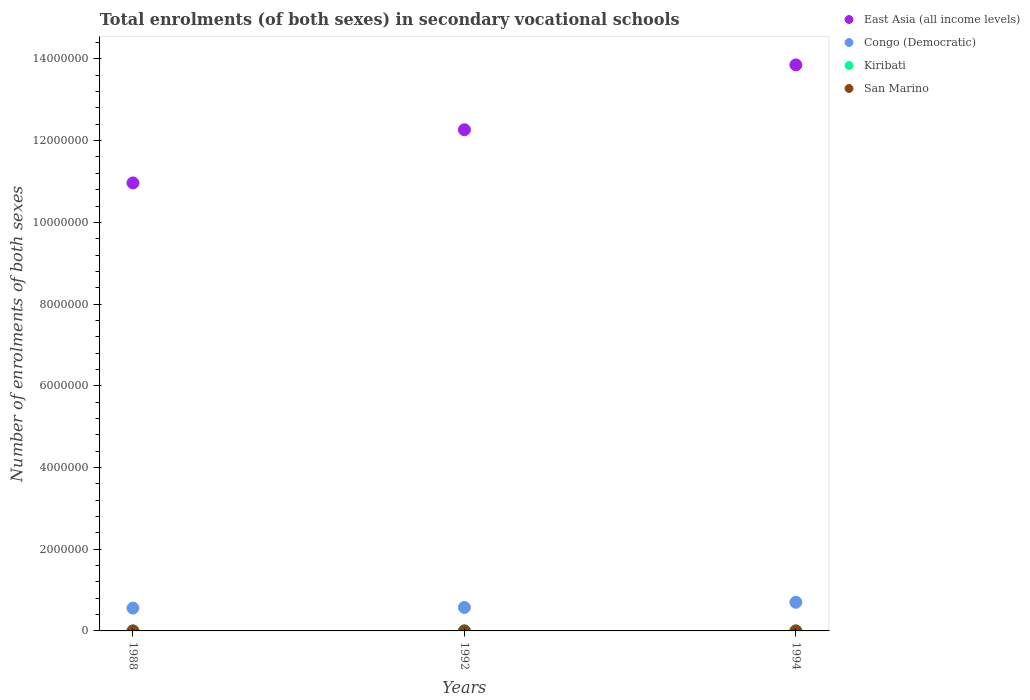How many different coloured dotlines are there?
Offer a very short reply. 4. What is the number of enrolments in secondary schools in Congo (Democratic) in 1992?
Your answer should be compact. 5.74e+05. Across all years, what is the maximum number of enrolments in secondary schools in Congo (Democratic)?
Offer a very short reply. 7.01e+05. Across all years, what is the minimum number of enrolments in secondary schools in East Asia (all income levels)?
Give a very brief answer. 1.10e+07. What is the total number of enrolments in secondary schools in San Marino in the graph?
Give a very brief answer. 414. What is the difference between the number of enrolments in secondary schools in San Marino in 1988 and that in 1992?
Provide a succinct answer. -23. What is the difference between the number of enrolments in secondary schools in East Asia (all income levels) in 1988 and the number of enrolments in secondary schools in San Marino in 1994?
Ensure brevity in your answer.  1.10e+07. What is the average number of enrolments in secondary schools in Congo (Democratic) per year?
Give a very brief answer. 6.11e+05. In the year 1988, what is the difference between the number of enrolments in secondary schools in East Asia (all income levels) and number of enrolments in secondary schools in San Marino?
Your answer should be compact. 1.10e+07. What is the ratio of the number of enrolments in secondary schools in Congo (Democratic) in 1992 to that in 1994?
Provide a short and direct response. 0.82. Is the number of enrolments in secondary schools in East Asia (all income levels) in 1992 less than that in 1994?
Offer a terse response. Yes. What is the difference between the highest and the second highest number of enrolments in secondary schools in East Asia (all income levels)?
Keep it short and to the point. 1.59e+06. What is the difference between the highest and the lowest number of enrolments in secondary schools in East Asia (all income levels)?
Provide a succinct answer. 2.89e+06. In how many years, is the number of enrolments in secondary schools in Congo (Democratic) greater than the average number of enrolments in secondary schools in Congo (Democratic) taken over all years?
Offer a terse response. 1. Is the sum of the number of enrolments in secondary schools in Congo (Democratic) in 1992 and 1994 greater than the maximum number of enrolments in secondary schools in San Marino across all years?
Ensure brevity in your answer.  Yes. Is it the case that in every year, the sum of the number of enrolments in secondary schools in Congo (Democratic) and number of enrolments in secondary schools in East Asia (all income levels)  is greater than the sum of number of enrolments in secondary schools in Kiribati and number of enrolments in secondary schools in San Marino?
Ensure brevity in your answer.  Yes. Is it the case that in every year, the sum of the number of enrolments in secondary schools in San Marino and number of enrolments in secondary schools in Congo (Democratic)  is greater than the number of enrolments in secondary schools in Kiribati?
Your response must be concise. Yes. Is the number of enrolments in secondary schools in San Marino strictly greater than the number of enrolments in secondary schools in Kiribati over the years?
Make the answer very short. No. Is the number of enrolments in secondary schools in East Asia (all income levels) strictly less than the number of enrolments in secondary schools in Kiribati over the years?
Keep it short and to the point. No. How many dotlines are there?
Ensure brevity in your answer.  4. What is the difference between two consecutive major ticks on the Y-axis?
Offer a very short reply. 2.00e+06. Does the graph contain any zero values?
Provide a succinct answer. No. Does the graph contain grids?
Make the answer very short. No. Where does the legend appear in the graph?
Make the answer very short. Top right. How many legend labels are there?
Ensure brevity in your answer.  4. What is the title of the graph?
Provide a short and direct response. Total enrolments (of both sexes) in secondary vocational schools. Does "Brazil" appear as one of the legend labels in the graph?
Ensure brevity in your answer.  No. What is the label or title of the Y-axis?
Keep it short and to the point. Number of enrolments of both sexes. What is the Number of enrolments of both sexes in East Asia (all income levels) in 1988?
Offer a very short reply. 1.10e+07. What is the Number of enrolments of both sexes of Congo (Democratic) in 1988?
Give a very brief answer. 5.58e+05. What is the Number of enrolments of both sexes of Kiribati in 1988?
Your answer should be very brief. 410. What is the Number of enrolments of both sexes in San Marino in 1988?
Offer a very short reply. 114. What is the Number of enrolments of both sexes in East Asia (all income levels) in 1992?
Provide a short and direct response. 1.23e+07. What is the Number of enrolments of both sexes in Congo (Democratic) in 1992?
Your answer should be compact. 5.74e+05. What is the Number of enrolments of both sexes in Kiribati in 1992?
Make the answer very short. 288. What is the Number of enrolments of both sexes of San Marino in 1992?
Make the answer very short. 137. What is the Number of enrolments of both sexes in East Asia (all income levels) in 1994?
Provide a short and direct response. 1.39e+07. What is the Number of enrolments of both sexes in Congo (Democratic) in 1994?
Make the answer very short. 7.01e+05. What is the Number of enrolments of both sexes of Kiribati in 1994?
Keep it short and to the point. 352. What is the Number of enrolments of both sexes of San Marino in 1994?
Provide a short and direct response. 163. Across all years, what is the maximum Number of enrolments of both sexes of East Asia (all income levels)?
Your response must be concise. 1.39e+07. Across all years, what is the maximum Number of enrolments of both sexes of Congo (Democratic)?
Offer a very short reply. 7.01e+05. Across all years, what is the maximum Number of enrolments of both sexes of Kiribati?
Provide a short and direct response. 410. Across all years, what is the maximum Number of enrolments of both sexes in San Marino?
Provide a succinct answer. 163. Across all years, what is the minimum Number of enrolments of both sexes of East Asia (all income levels)?
Your answer should be compact. 1.10e+07. Across all years, what is the minimum Number of enrolments of both sexes in Congo (Democratic)?
Your response must be concise. 5.58e+05. Across all years, what is the minimum Number of enrolments of both sexes of Kiribati?
Your answer should be compact. 288. Across all years, what is the minimum Number of enrolments of both sexes of San Marino?
Provide a succinct answer. 114. What is the total Number of enrolments of both sexes of East Asia (all income levels) in the graph?
Offer a terse response. 3.71e+07. What is the total Number of enrolments of both sexes of Congo (Democratic) in the graph?
Your response must be concise. 1.83e+06. What is the total Number of enrolments of both sexes of Kiribati in the graph?
Offer a very short reply. 1050. What is the total Number of enrolments of both sexes of San Marino in the graph?
Make the answer very short. 414. What is the difference between the Number of enrolments of both sexes in East Asia (all income levels) in 1988 and that in 1992?
Provide a succinct answer. -1.30e+06. What is the difference between the Number of enrolments of both sexes of Congo (Democratic) in 1988 and that in 1992?
Your answer should be compact. -1.60e+04. What is the difference between the Number of enrolments of both sexes in Kiribati in 1988 and that in 1992?
Offer a terse response. 122. What is the difference between the Number of enrolments of both sexes in East Asia (all income levels) in 1988 and that in 1994?
Provide a short and direct response. -2.89e+06. What is the difference between the Number of enrolments of both sexes in Congo (Democratic) in 1988 and that in 1994?
Offer a terse response. -1.43e+05. What is the difference between the Number of enrolments of both sexes of San Marino in 1988 and that in 1994?
Offer a very short reply. -49. What is the difference between the Number of enrolments of both sexes in East Asia (all income levels) in 1992 and that in 1994?
Provide a succinct answer. -1.59e+06. What is the difference between the Number of enrolments of both sexes in Congo (Democratic) in 1992 and that in 1994?
Offer a terse response. -1.27e+05. What is the difference between the Number of enrolments of both sexes in Kiribati in 1992 and that in 1994?
Give a very brief answer. -64. What is the difference between the Number of enrolments of both sexes in East Asia (all income levels) in 1988 and the Number of enrolments of both sexes in Congo (Democratic) in 1992?
Ensure brevity in your answer.  1.04e+07. What is the difference between the Number of enrolments of both sexes of East Asia (all income levels) in 1988 and the Number of enrolments of both sexes of Kiribati in 1992?
Your answer should be compact. 1.10e+07. What is the difference between the Number of enrolments of both sexes in East Asia (all income levels) in 1988 and the Number of enrolments of both sexes in San Marino in 1992?
Keep it short and to the point. 1.10e+07. What is the difference between the Number of enrolments of both sexes of Congo (Democratic) in 1988 and the Number of enrolments of both sexes of Kiribati in 1992?
Your response must be concise. 5.58e+05. What is the difference between the Number of enrolments of both sexes in Congo (Democratic) in 1988 and the Number of enrolments of both sexes in San Marino in 1992?
Your answer should be compact. 5.58e+05. What is the difference between the Number of enrolments of both sexes in Kiribati in 1988 and the Number of enrolments of both sexes in San Marino in 1992?
Your response must be concise. 273. What is the difference between the Number of enrolments of both sexes in East Asia (all income levels) in 1988 and the Number of enrolments of both sexes in Congo (Democratic) in 1994?
Offer a terse response. 1.03e+07. What is the difference between the Number of enrolments of both sexes of East Asia (all income levels) in 1988 and the Number of enrolments of both sexes of Kiribati in 1994?
Keep it short and to the point. 1.10e+07. What is the difference between the Number of enrolments of both sexes in East Asia (all income levels) in 1988 and the Number of enrolments of both sexes in San Marino in 1994?
Your response must be concise. 1.10e+07. What is the difference between the Number of enrolments of both sexes of Congo (Democratic) in 1988 and the Number of enrolments of both sexes of Kiribati in 1994?
Keep it short and to the point. 5.58e+05. What is the difference between the Number of enrolments of both sexes in Congo (Democratic) in 1988 and the Number of enrolments of both sexes in San Marino in 1994?
Keep it short and to the point. 5.58e+05. What is the difference between the Number of enrolments of both sexes of Kiribati in 1988 and the Number of enrolments of both sexes of San Marino in 1994?
Your response must be concise. 247. What is the difference between the Number of enrolments of both sexes in East Asia (all income levels) in 1992 and the Number of enrolments of both sexes in Congo (Democratic) in 1994?
Your response must be concise. 1.16e+07. What is the difference between the Number of enrolments of both sexes in East Asia (all income levels) in 1992 and the Number of enrolments of both sexes in Kiribati in 1994?
Give a very brief answer. 1.23e+07. What is the difference between the Number of enrolments of both sexes of East Asia (all income levels) in 1992 and the Number of enrolments of both sexes of San Marino in 1994?
Your answer should be compact. 1.23e+07. What is the difference between the Number of enrolments of both sexes of Congo (Democratic) in 1992 and the Number of enrolments of both sexes of Kiribati in 1994?
Keep it short and to the point. 5.74e+05. What is the difference between the Number of enrolments of both sexes of Congo (Democratic) in 1992 and the Number of enrolments of both sexes of San Marino in 1994?
Ensure brevity in your answer.  5.74e+05. What is the difference between the Number of enrolments of both sexes in Kiribati in 1992 and the Number of enrolments of both sexes in San Marino in 1994?
Keep it short and to the point. 125. What is the average Number of enrolments of both sexes in East Asia (all income levels) per year?
Your answer should be very brief. 1.24e+07. What is the average Number of enrolments of both sexes in Congo (Democratic) per year?
Provide a short and direct response. 6.11e+05. What is the average Number of enrolments of both sexes in Kiribati per year?
Ensure brevity in your answer.  350. What is the average Number of enrolments of both sexes of San Marino per year?
Provide a succinct answer. 138. In the year 1988, what is the difference between the Number of enrolments of both sexes in East Asia (all income levels) and Number of enrolments of both sexes in Congo (Democratic)?
Keep it short and to the point. 1.04e+07. In the year 1988, what is the difference between the Number of enrolments of both sexes of East Asia (all income levels) and Number of enrolments of both sexes of Kiribati?
Offer a terse response. 1.10e+07. In the year 1988, what is the difference between the Number of enrolments of both sexes in East Asia (all income levels) and Number of enrolments of both sexes in San Marino?
Your answer should be very brief. 1.10e+07. In the year 1988, what is the difference between the Number of enrolments of both sexes in Congo (Democratic) and Number of enrolments of both sexes in Kiribati?
Ensure brevity in your answer.  5.58e+05. In the year 1988, what is the difference between the Number of enrolments of both sexes in Congo (Democratic) and Number of enrolments of both sexes in San Marino?
Provide a succinct answer. 5.58e+05. In the year 1988, what is the difference between the Number of enrolments of both sexes of Kiribati and Number of enrolments of both sexes of San Marino?
Your response must be concise. 296. In the year 1992, what is the difference between the Number of enrolments of both sexes in East Asia (all income levels) and Number of enrolments of both sexes in Congo (Democratic)?
Offer a very short reply. 1.17e+07. In the year 1992, what is the difference between the Number of enrolments of both sexes of East Asia (all income levels) and Number of enrolments of both sexes of Kiribati?
Keep it short and to the point. 1.23e+07. In the year 1992, what is the difference between the Number of enrolments of both sexes in East Asia (all income levels) and Number of enrolments of both sexes in San Marino?
Your answer should be compact. 1.23e+07. In the year 1992, what is the difference between the Number of enrolments of both sexes of Congo (Democratic) and Number of enrolments of both sexes of Kiribati?
Make the answer very short. 5.74e+05. In the year 1992, what is the difference between the Number of enrolments of both sexes of Congo (Democratic) and Number of enrolments of both sexes of San Marino?
Provide a succinct answer. 5.74e+05. In the year 1992, what is the difference between the Number of enrolments of both sexes in Kiribati and Number of enrolments of both sexes in San Marino?
Offer a terse response. 151. In the year 1994, what is the difference between the Number of enrolments of both sexes in East Asia (all income levels) and Number of enrolments of both sexes in Congo (Democratic)?
Provide a succinct answer. 1.32e+07. In the year 1994, what is the difference between the Number of enrolments of both sexes in East Asia (all income levels) and Number of enrolments of both sexes in Kiribati?
Ensure brevity in your answer.  1.39e+07. In the year 1994, what is the difference between the Number of enrolments of both sexes of East Asia (all income levels) and Number of enrolments of both sexes of San Marino?
Make the answer very short. 1.39e+07. In the year 1994, what is the difference between the Number of enrolments of both sexes in Congo (Democratic) and Number of enrolments of both sexes in Kiribati?
Offer a terse response. 7.01e+05. In the year 1994, what is the difference between the Number of enrolments of both sexes of Congo (Democratic) and Number of enrolments of both sexes of San Marino?
Offer a very short reply. 7.01e+05. In the year 1994, what is the difference between the Number of enrolments of both sexes of Kiribati and Number of enrolments of both sexes of San Marino?
Provide a short and direct response. 189. What is the ratio of the Number of enrolments of both sexes in East Asia (all income levels) in 1988 to that in 1992?
Your answer should be compact. 0.89. What is the ratio of the Number of enrolments of both sexes of Congo (Democratic) in 1988 to that in 1992?
Provide a succinct answer. 0.97. What is the ratio of the Number of enrolments of both sexes of Kiribati in 1988 to that in 1992?
Your answer should be very brief. 1.42. What is the ratio of the Number of enrolments of both sexes in San Marino in 1988 to that in 1992?
Provide a succinct answer. 0.83. What is the ratio of the Number of enrolments of both sexes of East Asia (all income levels) in 1988 to that in 1994?
Ensure brevity in your answer.  0.79. What is the ratio of the Number of enrolments of both sexes of Congo (Democratic) in 1988 to that in 1994?
Your answer should be very brief. 0.8. What is the ratio of the Number of enrolments of both sexes of Kiribati in 1988 to that in 1994?
Your answer should be very brief. 1.16. What is the ratio of the Number of enrolments of both sexes of San Marino in 1988 to that in 1994?
Ensure brevity in your answer.  0.7. What is the ratio of the Number of enrolments of both sexes in East Asia (all income levels) in 1992 to that in 1994?
Make the answer very short. 0.89. What is the ratio of the Number of enrolments of both sexes of Congo (Democratic) in 1992 to that in 1994?
Your response must be concise. 0.82. What is the ratio of the Number of enrolments of both sexes in Kiribati in 1992 to that in 1994?
Make the answer very short. 0.82. What is the ratio of the Number of enrolments of both sexes of San Marino in 1992 to that in 1994?
Ensure brevity in your answer.  0.84. What is the difference between the highest and the second highest Number of enrolments of both sexes of East Asia (all income levels)?
Your answer should be very brief. 1.59e+06. What is the difference between the highest and the second highest Number of enrolments of both sexes of Congo (Democratic)?
Provide a short and direct response. 1.27e+05. What is the difference between the highest and the second highest Number of enrolments of both sexes of Kiribati?
Give a very brief answer. 58. What is the difference between the highest and the lowest Number of enrolments of both sexes of East Asia (all income levels)?
Make the answer very short. 2.89e+06. What is the difference between the highest and the lowest Number of enrolments of both sexes of Congo (Democratic)?
Keep it short and to the point. 1.43e+05. What is the difference between the highest and the lowest Number of enrolments of both sexes of Kiribati?
Make the answer very short. 122. What is the difference between the highest and the lowest Number of enrolments of both sexes of San Marino?
Your answer should be compact. 49. 